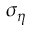Convert formula to latex. <formula><loc_0><loc_0><loc_500><loc_500>\sigma _ { \eta }</formula> 